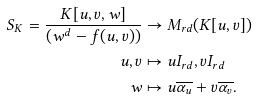<formula> <loc_0><loc_0><loc_500><loc_500>S _ { K } = \frac { K [ u , v , w ] } { ( w ^ { d } - f ( u , v ) ) } & \to M _ { r d } ( K [ u , v ] ) \\ u , v & \mapsto u I _ { r d } , v I _ { r d } \\ w & \mapsto u \overline { \alpha _ { u } } + v \overline { \alpha _ { v } } .</formula> 